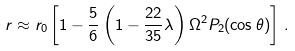Convert formula to latex. <formula><loc_0><loc_0><loc_500><loc_500>r \approx r _ { 0 } \left [ 1 - \frac { 5 } { 6 } \left ( 1 - \frac { 2 2 } { 3 5 } \lambda \right ) \Omega ^ { 2 } P _ { 2 } ( \cos \theta ) \right ] \, .</formula> 